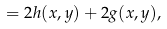<formula> <loc_0><loc_0><loc_500><loc_500>= 2 h ( x , y ) + 2 g ( x , y ) ,</formula> 